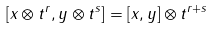Convert formula to latex. <formula><loc_0><loc_0><loc_500><loc_500>[ x \otimes t ^ { r } , y \otimes t ^ { s } ] = [ x , y ] \otimes t ^ { r + s }</formula> 